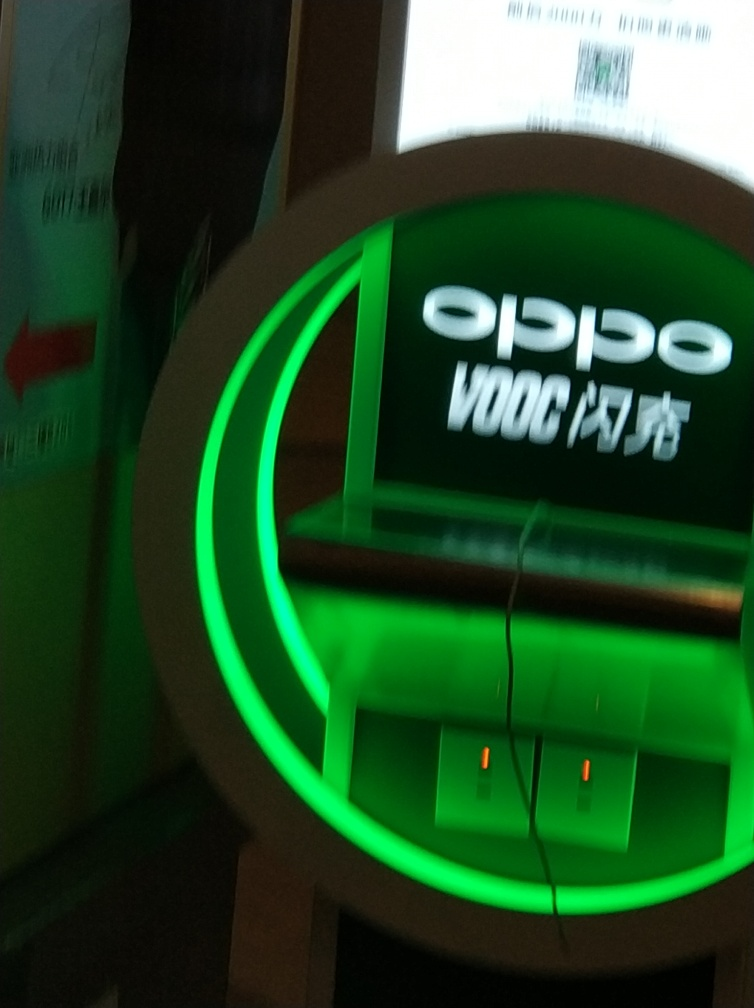Can you explain the green lighting in the image and what it might signify? The green lighting in the image seems to be part of a branded charging station, possibly indicating a high-speed or rapid charging feature for electronic devices, such as smartphones. Green lighting is often used to symbolize power, energy, and progress which aligns with the concept of fast charging technology. Is there anything in the image that suggests where this might be located? Although the specific location is not clear from the image, the presence of a charging station suggests it could be a public area such as an airport, mall, or a transit station. These places often have charging stations for people to recharge their devices on-the-go. 